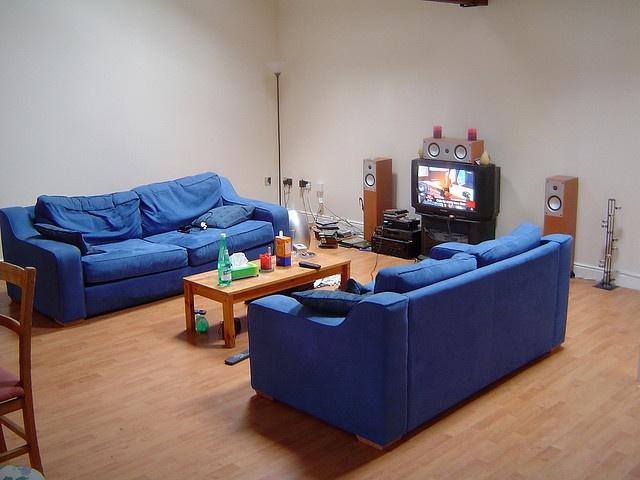Describe the objects in this image and their specific colors. I can see couch in darkgray, navy, black, and gray tones, couch in darkgray, navy, black, blue, and gray tones, chair in darkgray, maroon, gray, and black tones, tv in darkgray, black, white, gray, and lightpink tones, and bottle in darkgray and teal tones in this image. 